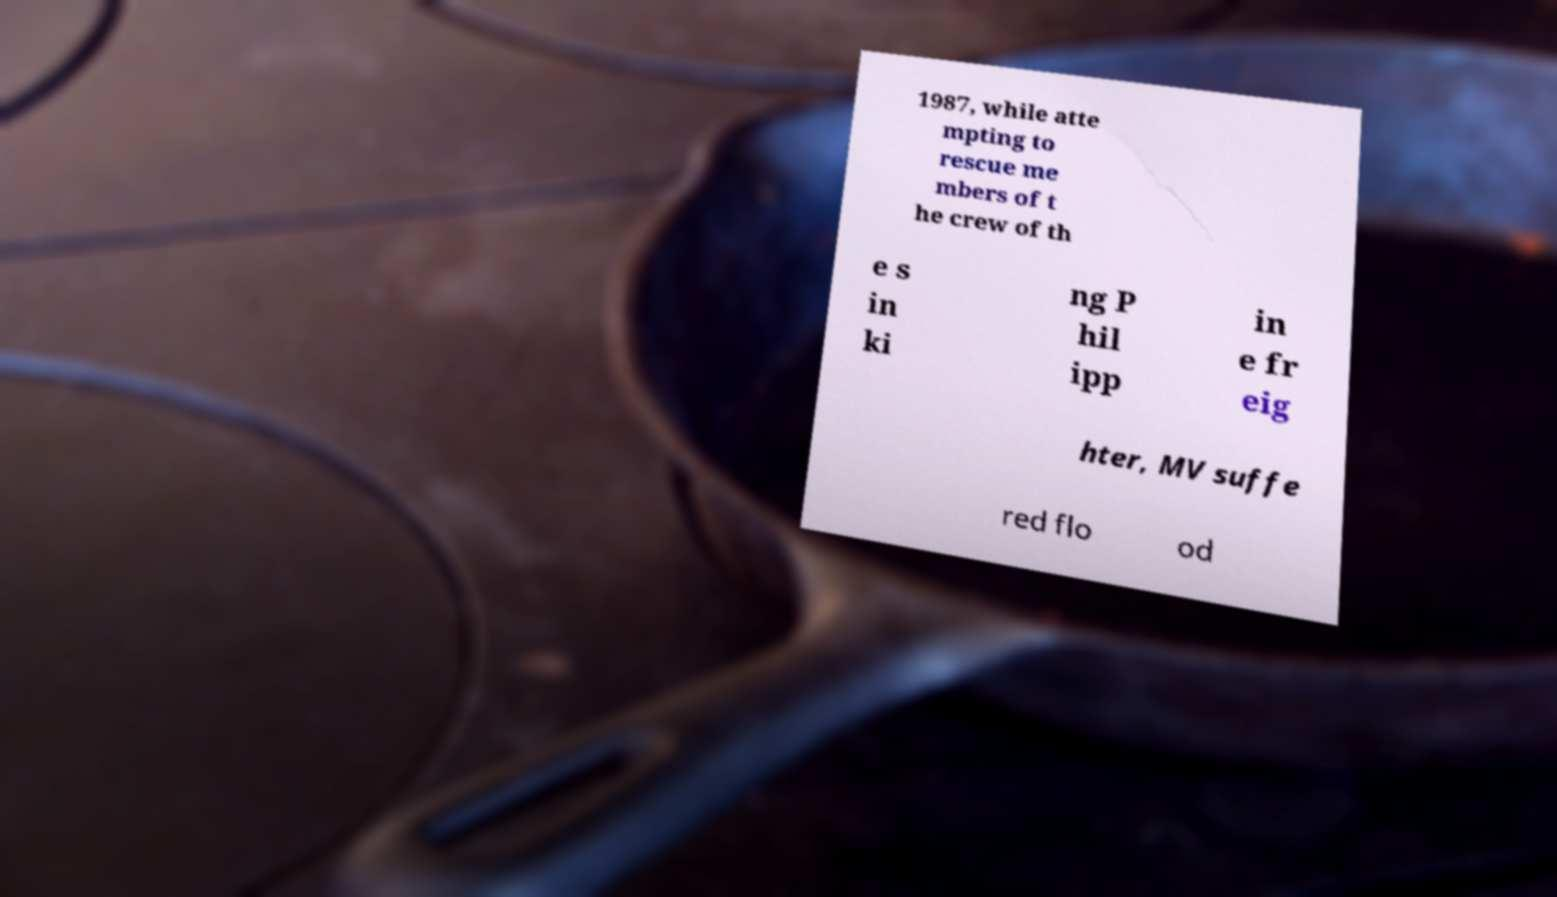For documentation purposes, I need the text within this image transcribed. Could you provide that? 1987, while atte mpting to rescue me mbers of t he crew of th e s in ki ng P hil ipp in e fr eig hter, MV suffe red flo od 